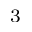Convert formula to latex. <formula><loc_0><loc_0><loc_500><loc_500>_ { 3 }</formula> 